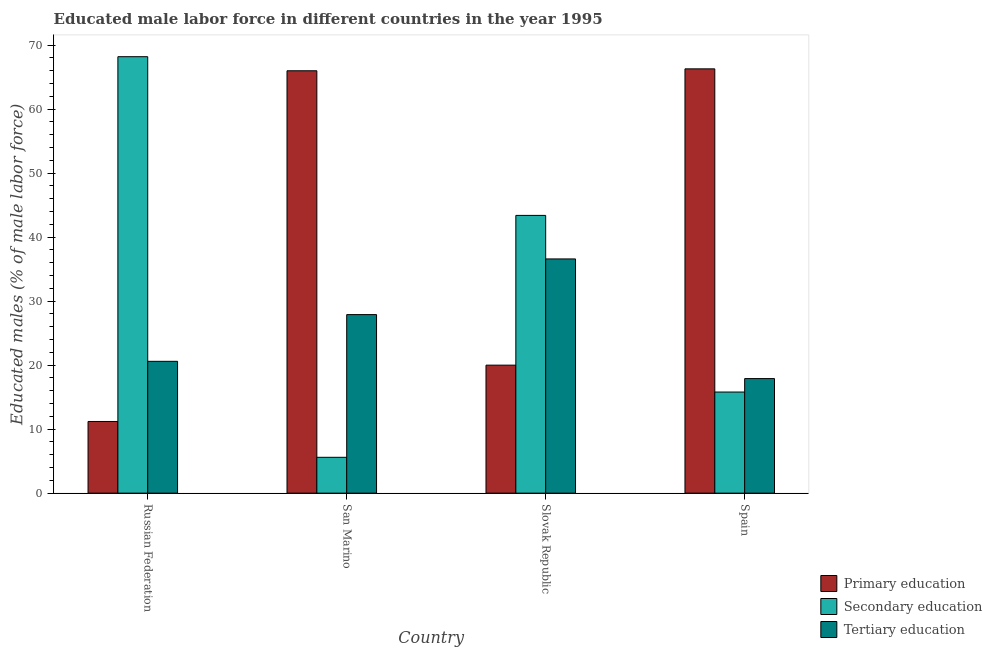How many different coloured bars are there?
Offer a terse response. 3. Are the number of bars per tick equal to the number of legend labels?
Make the answer very short. Yes. How many bars are there on the 2nd tick from the left?
Your response must be concise. 3. What is the label of the 3rd group of bars from the left?
Keep it short and to the point. Slovak Republic. What is the percentage of male labor force who received tertiary education in San Marino?
Your answer should be compact. 27.9. Across all countries, what is the maximum percentage of male labor force who received secondary education?
Make the answer very short. 68.2. Across all countries, what is the minimum percentage of male labor force who received tertiary education?
Keep it short and to the point. 17.9. In which country was the percentage of male labor force who received tertiary education maximum?
Give a very brief answer. Slovak Republic. In which country was the percentage of male labor force who received tertiary education minimum?
Offer a very short reply. Spain. What is the total percentage of male labor force who received secondary education in the graph?
Your response must be concise. 133. What is the difference between the percentage of male labor force who received secondary education in Russian Federation and that in San Marino?
Your answer should be compact. 62.6. What is the difference between the percentage of male labor force who received tertiary education in Slovak Republic and the percentage of male labor force who received secondary education in Spain?
Offer a very short reply. 20.8. What is the average percentage of male labor force who received tertiary education per country?
Your response must be concise. 25.75. What is the difference between the percentage of male labor force who received tertiary education and percentage of male labor force who received primary education in San Marino?
Give a very brief answer. -38.1. In how many countries, is the percentage of male labor force who received tertiary education greater than 12 %?
Your response must be concise. 4. What is the ratio of the percentage of male labor force who received tertiary education in San Marino to that in Slovak Republic?
Keep it short and to the point. 0.76. Is the percentage of male labor force who received secondary education in Slovak Republic less than that in Spain?
Provide a succinct answer. No. Is the difference between the percentage of male labor force who received tertiary education in Slovak Republic and Spain greater than the difference between the percentage of male labor force who received secondary education in Slovak Republic and Spain?
Offer a terse response. No. What is the difference between the highest and the second highest percentage of male labor force who received secondary education?
Make the answer very short. 24.8. What is the difference between the highest and the lowest percentage of male labor force who received primary education?
Give a very brief answer. 55.1. In how many countries, is the percentage of male labor force who received tertiary education greater than the average percentage of male labor force who received tertiary education taken over all countries?
Your response must be concise. 2. What does the 3rd bar from the left in Spain represents?
Make the answer very short. Tertiary education. What does the 3rd bar from the right in Russian Federation represents?
Ensure brevity in your answer.  Primary education. Is it the case that in every country, the sum of the percentage of male labor force who received primary education and percentage of male labor force who received secondary education is greater than the percentage of male labor force who received tertiary education?
Make the answer very short. Yes. How many bars are there?
Your answer should be compact. 12. Are all the bars in the graph horizontal?
Make the answer very short. No. How many countries are there in the graph?
Make the answer very short. 4. Where does the legend appear in the graph?
Your response must be concise. Bottom right. What is the title of the graph?
Make the answer very short. Educated male labor force in different countries in the year 1995. Does "Ores and metals" appear as one of the legend labels in the graph?
Offer a very short reply. No. What is the label or title of the Y-axis?
Offer a terse response. Educated males (% of male labor force). What is the Educated males (% of male labor force) in Primary education in Russian Federation?
Keep it short and to the point. 11.2. What is the Educated males (% of male labor force) of Secondary education in Russian Federation?
Keep it short and to the point. 68.2. What is the Educated males (% of male labor force) of Tertiary education in Russian Federation?
Offer a terse response. 20.6. What is the Educated males (% of male labor force) in Secondary education in San Marino?
Your answer should be very brief. 5.6. What is the Educated males (% of male labor force) of Tertiary education in San Marino?
Your answer should be compact. 27.9. What is the Educated males (% of male labor force) of Primary education in Slovak Republic?
Ensure brevity in your answer.  20. What is the Educated males (% of male labor force) in Secondary education in Slovak Republic?
Your answer should be very brief. 43.4. What is the Educated males (% of male labor force) of Tertiary education in Slovak Republic?
Ensure brevity in your answer.  36.6. What is the Educated males (% of male labor force) of Primary education in Spain?
Give a very brief answer. 66.3. What is the Educated males (% of male labor force) in Secondary education in Spain?
Your answer should be compact. 15.8. What is the Educated males (% of male labor force) in Tertiary education in Spain?
Provide a short and direct response. 17.9. Across all countries, what is the maximum Educated males (% of male labor force) of Primary education?
Provide a short and direct response. 66.3. Across all countries, what is the maximum Educated males (% of male labor force) of Secondary education?
Offer a terse response. 68.2. Across all countries, what is the maximum Educated males (% of male labor force) of Tertiary education?
Keep it short and to the point. 36.6. Across all countries, what is the minimum Educated males (% of male labor force) of Primary education?
Keep it short and to the point. 11.2. Across all countries, what is the minimum Educated males (% of male labor force) of Secondary education?
Make the answer very short. 5.6. Across all countries, what is the minimum Educated males (% of male labor force) in Tertiary education?
Give a very brief answer. 17.9. What is the total Educated males (% of male labor force) in Primary education in the graph?
Keep it short and to the point. 163.5. What is the total Educated males (% of male labor force) of Secondary education in the graph?
Your answer should be very brief. 133. What is the total Educated males (% of male labor force) in Tertiary education in the graph?
Provide a succinct answer. 103. What is the difference between the Educated males (% of male labor force) of Primary education in Russian Federation and that in San Marino?
Keep it short and to the point. -54.8. What is the difference between the Educated males (% of male labor force) of Secondary education in Russian Federation and that in San Marino?
Provide a short and direct response. 62.6. What is the difference between the Educated males (% of male labor force) in Primary education in Russian Federation and that in Slovak Republic?
Offer a terse response. -8.8. What is the difference between the Educated males (% of male labor force) of Secondary education in Russian Federation and that in Slovak Republic?
Give a very brief answer. 24.8. What is the difference between the Educated males (% of male labor force) of Primary education in Russian Federation and that in Spain?
Your answer should be compact. -55.1. What is the difference between the Educated males (% of male labor force) in Secondary education in Russian Federation and that in Spain?
Keep it short and to the point. 52.4. What is the difference between the Educated males (% of male labor force) in Primary education in San Marino and that in Slovak Republic?
Give a very brief answer. 46. What is the difference between the Educated males (% of male labor force) in Secondary education in San Marino and that in Slovak Republic?
Keep it short and to the point. -37.8. What is the difference between the Educated males (% of male labor force) in Primary education in San Marino and that in Spain?
Keep it short and to the point. -0.3. What is the difference between the Educated males (% of male labor force) of Secondary education in San Marino and that in Spain?
Your answer should be compact. -10.2. What is the difference between the Educated males (% of male labor force) in Tertiary education in San Marino and that in Spain?
Provide a succinct answer. 10. What is the difference between the Educated males (% of male labor force) of Primary education in Slovak Republic and that in Spain?
Offer a terse response. -46.3. What is the difference between the Educated males (% of male labor force) of Secondary education in Slovak Republic and that in Spain?
Your answer should be very brief. 27.6. What is the difference between the Educated males (% of male labor force) of Primary education in Russian Federation and the Educated males (% of male labor force) of Tertiary education in San Marino?
Provide a short and direct response. -16.7. What is the difference between the Educated males (% of male labor force) in Secondary education in Russian Federation and the Educated males (% of male labor force) in Tertiary education in San Marino?
Keep it short and to the point. 40.3. What is the difference between the Educated males (% of male labor force) in Primary education in Russian Federation and the Educated males (% of male labor force) in Secondary education in Slovak Republic?
Give a very brief answer. -32.2. What is the difference between the Educated males (% of male labor force) in Primary education in Russian Federation and the Educated males (% of male labor force) in Tertiary education in Slovak Republic?
Your response must be concise. -25.4. What is the difference between the Educated males (% of male labor force) of Secondary education in Russian Federation and the Educated males (% of male labor force) of Tertiary education in Slovak Republic?
Make the answer very short. 31.6. What is the difference between the Educated males (% of male labor force) in Primary education in Russian Federation and the Educated males (% of male labor force) in Tertiary education in Spain?
Your response must be concise. -6.7. What is the difference between the Educated males (% of male labor force) of Secondary education in Russian Federation and the Educated males (% of male labor force) of Tertiary education in Spain?
Your response must be concise. 50.3. What is the difference between the Educated males (% of male labor force) in Primary education in San Marino and the Educated males (% of male labor force) in Secondary education in Slovak Republic?
Provide a succinct answer. 22.6. What is the difference between the Educated males (% of male labor force) in Primary education in San Marino and the Educated males (% of male labor force) in Tertiary education in Slovak Republic?
Make the answer very short. 29.4. What is the difference between the Educated males (% of male labor force) of Secondary education in San Marino and the Educated males (% of male labor force) of Tertiary education in Slovak Republic?
Make the answer very short. -31. What is the difference between the Educated males (% of male labor force) of Primary education in San Marino and the Educated males (% of male labor force) of Secondary education in Spain?
Your answer should be very brief. 50.2. What is the difference between the Educated males (% of male labor force) of Primary education in San Marino and the Educated males (% of male labor force) of Tertiary education in Spain?
Provide a short and direct response. 48.1. What is the difference between the Educated males (% of male labor force) in Secondary education in San Marino and the Educated males (% of male labor force) in Tertiary education in Spain?
Your answer should be very brief. -12.3. What is the difference between the Educated males (% of male labor force) of Primary education in Slovak Republic and the Educated males (% of male labor force) of Tertiary education in Spain?
Offer a very short reply. 2.1. What is the difference between the Educated males (% of male labor force) of Secondary education in Slovak Republic and the Educated males (% of male labor force) of Tertiary education in Spain?
Offer a terse response. 25.5. What is the average Educated males (% of male labor force) in Primary education per country?
Your response must be concise. 40.88. What is the average Educated males (% of male labor force) in Secondary education per country?
Provide a succinct answer. 33.25. What is the average Educated males (% of male labor force) in Tertiary education per country?
Provide a short and direct response. 25.75. What is the difference between the Educated males (% of male labor force) of Primary education and Educated males (% of male labor force) of Secondary education in Russian Federation?
Your answer should be compact. -57. What is the difference between the Educated males (% of male labor force) of Secondary education and Educated males (% of male labor force) of Tertiary education in Russian Federation?
Provide a succinct answer. 47.6. What is the difference between the Educated males (% of male labor force) of Primary education and Educated males (% of male labor force) of Secondary education in San Marino?
Your response must be concise. 60.4. What is the difference between the Educated males (% of male labor force) of Primary education and Educated males (% of male labor force) of Tertiary education in San Marino?
Keep it short and to the point. 38.1. What is the difference between the Educated males (% of male labor force) in Secondary education and Educated males (% of male labor force) in Tertiary education in San Marino?
Your answer should be very brief. -22.3. What is the difference between the Educated males (% of male labor force) in Primary education and Educated males (% of male labor force) in Secondary education in Slovak Republic?
Your answer should be very brief. -23.4. What is the difference between the Educated males (% of male labor force) in Primary education and Educated males (% of male labor force) in Tertiary education in Slovak Republic?
Your answer should be very brief. -16.6. What is the difference between the Educated males (% of male labor force) of Primary education and Educated males (% of male labor force) of Secondary education in Spain?
Provide a short and direct response. 50.5. What is the difference between the Educated males (% of male labor force) in Primary education and Educated males (% of male labor force) in Tertiary education in Spain?
Give a very brief answer. 48.4. What is the difference between the Educated males (% of male labor force) in Secondary education and Educated males (% of male labor force) in Tertiary education in Spain?
Your answer should be compact. -2.1. What is the ratio of the Educated males (% of male labor force) in Primary education in Russian Federation to that in San Marino?
Provide a short and direct response. 0.17. What is the ratio of the Educated males (% of male labor force) of Secondary education in Russian Federation to that in San Marino?
Offer a very short reply. 12.18. What is the ratio of the Educated males (% of male labor force) in Tertiary education in Russian Federation to that in San Marino?
Offer a terse response. 0.74. What is the ratio of the Educated males (% of male labor force) in Primary education in Russian Federation to that in Slovak Republic?
Make the answer very short. 0.56. What is the ratio of the Educated males (% of male labor force) of Secondary education in Russian Federation to that in Slovak Republic?
Your answer should be very brief. 1.57. What is the ratio of the Educated males (% of male labor force) of Tertiary education in Russian Federation to that in Slovak Republic?
Provide a short and direct response. 0.56. What is the ratio of the Educated males (% of male labor force) in Primary education in Russian Federation to that in Spain?
Keep it short and to the point. 0.17. What is the ratio of the Educated males (% of male labor force) of Secondary education in Russian Federation to that in Spain?
Your answer should be very brief. 4.32. What is the ratio of the Educated males (% of male labor force) of Tertiary education in Russian Federation to that in Spain?
Make the answer very short. 1.15. What is the ratio of the Educated males (% of male labor force) of Primary education in San Marino to that in Slovak Republic?
Your answer should be compact. 3.3. What is the ratio of the Educated males (% of male labor force) in Secondary education in San Marino to that in Slovak Republic?
Provide a succinct answer. 0.13. What is the ratio of the Educated males (% of male labor force) of Tertiary education in San Marino to that in Slovak Republic?
Keep it short and to the point. 0.76. What is the ratio of the Educated males (% of male labor force) in Primary education in San Marino to that in Spain?
Your answer should be very brief. 1. What is the ratio of the Educated males (% of male labor force) in Secondary education in San Marino to that in Spain?
Your response must be concise. 0.35. What is the ratio of the Educated males (% of male labor force) in Tertiary education in San Marino to that in Spain?
Your response must be concise. 1.56. What is the ratio of the Educated males (% of male labor force) of Primary education in Slovak Republic to that in Spain?
Your answer should be compact. 0.3. What is the ratio of the Educated males (% of male labor force) in Secondary education in Slovak Republic to that in Spain?
Keep it short and to the point. 2.75. What is the ratio of the Educated males (% of male labor force) in Tertiary education in Slovak Republic to that in Spain?
Your answer should be compact. 2.04. What is the difference between the highest and the second highest Educated males (% of male labor force) of Primary education?
Your answer should be very brief. 0.3. What is the difference between the highest and the second highest Educated males (% of male labor force) in Secondary education?
Offer a terse response. 24.8. What is the difference between the highest and the lowest Educated males (% of male labor force) of Primary education?
Provide a short and direct response. 55.1. What is the difference between the highest and the lowest Educated males (% of male labor force) in Secondary education?
Provide a succinct answer. 62.6. What is the difference between the highest and the lowest Educated males (% of male labor force) of Tertiary education?
Ensure brevity in your answer.  18.7. 